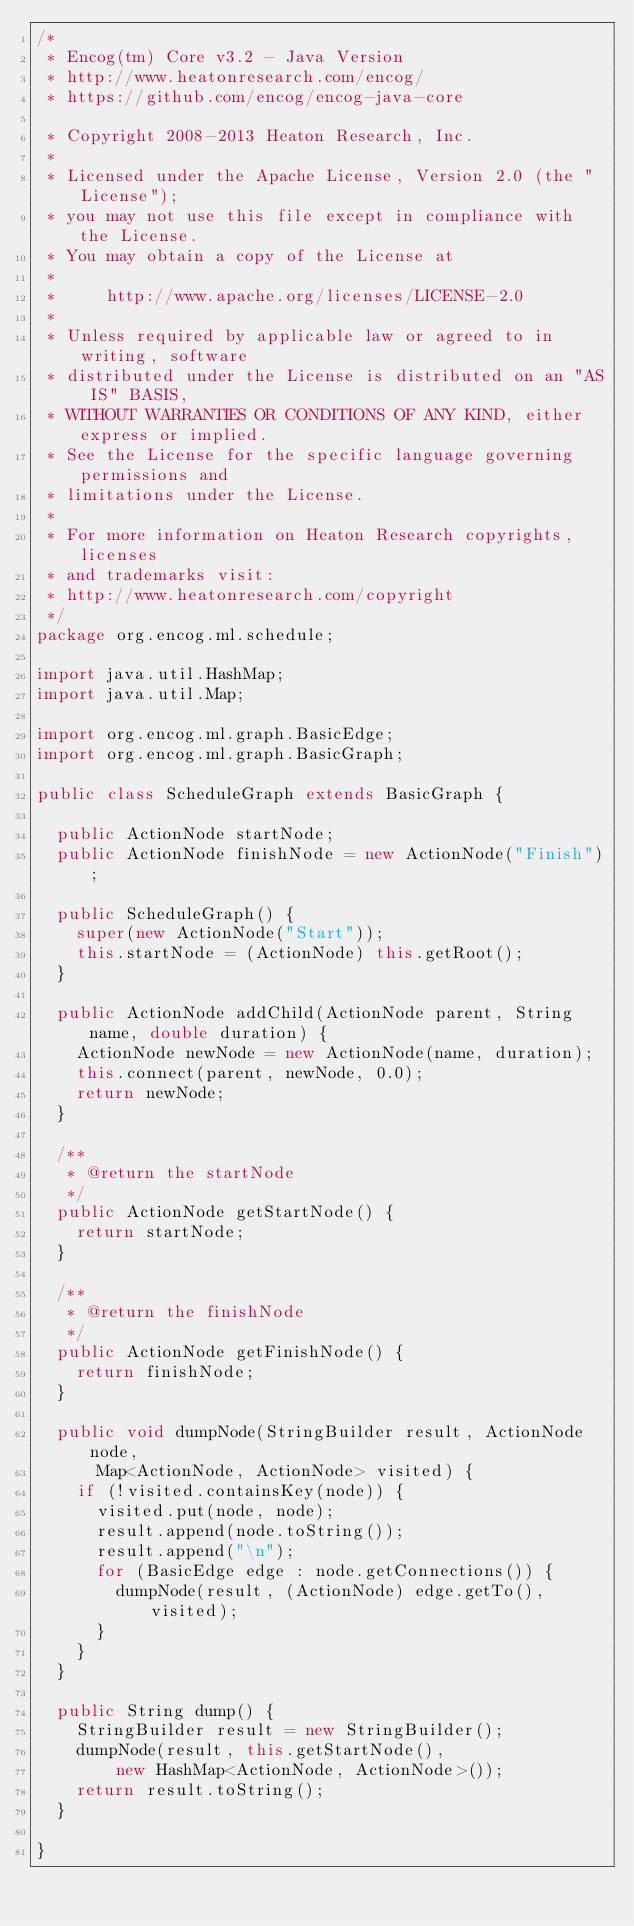Convert code to text. <code><loc_0><loc_0><loc_500><loc_500><_Java_>/*
 * Encog(tm) Core v3.2 - Java Version
 * http://www.heatonresearch.com/encog/
 * https://github.com/encog/encog-java-core
 
 * Copyright 2008-2013 Heaton Research, Inc.
 *
 * Licensed under the Apache License, Version 2.0 (the "License");
 * you may not use this file except in compliance with the License.
 * You may obtain a copy of the License at
 *
 *     http://www.apache.org/licenses/LICENSE-2.0
 *
 * Unless required by applicable law or agreed to in writing, software
 * distributed under the License is distributed on an "AS IS" BASIS,
 * WITHOUT WARRANTIES OR CONDITIONS OF ANY KIND, either express or implied.
 * See the License for the specific language governing permissions and
 * limitations under the License.
 *   
 * For more information on Heaton Research copyrights, licenses 
 * and trademarks visit:
 * http://www.heatonresearch.com/copyright
 */
package org.encog.ml.schedule;

import java.util.HashMap;
import java.util.Map;

import org.encog.ml.graph.BasicEdge;
import org.encog.ml.graph.BasicGraph;

public class ScheduleGraph extends BasicGraph {

	public ActionNode startNode;
	public ActionNode finishNode = new ActionNode("Finish");

	public ScheduleGraph() {
		super(new ActionNode("Start"));
		this.startNode = (ActionNode) this.getRoot();
	}

	public ActionNode addChild(ActionNode parent, String name, double duration) {
		ActionNode newNode = new ActionNode(name, duration);
		this.connect(parent, newNode, 0.0);
		return newNode;
	}

	/**
	 * @return the startNode
	 */
	public ActionNode getStartNode() {
		return startNode;
	}

	/**
	 * @return the finishNode
	 */
	public ActionNode getFinishNode() {
		return finishNode;
	}

	public void dumpNode(StringBuilder result, ActionNode node,
			Map<ActionNode, ActionNode> visited) {
		if (!visited.containsKey(node)) {
			visited.put(node, node);
			result.append(node.toString());
			result.append("\n");
			for (BasicEdge edge : node.getConnections()) {
				dumpNode(result, (ActionNode) edge.getTo(), visited);
			}
		}
	}

	public String dump() {
		StringBuilder result = new StringBuilder();
		dumpNode(result, this.getStartNode(),
				new HashMap<ActionNode, ActionNode>());
		return result.toString();
	}

}
</code> 